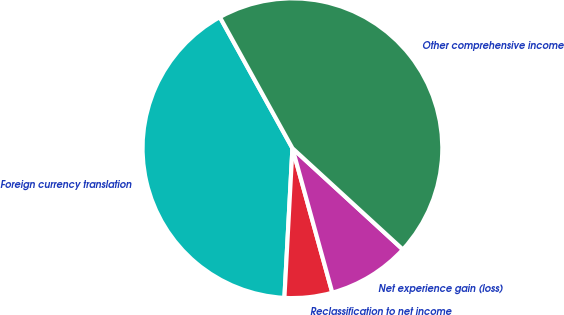Convert chart. <chart><loc_0><loc_0><loc_500><loc_500><pie_chart><fcel>Foreign currency translation<fcel>Reclassification to net income<fcel>Net experience gain (loss)<fcel>Other comprehensive income<nl><fcel>41.1%<fcel>5.14%<fcel>8.9%<fcel>44.86%<nl></chart> 